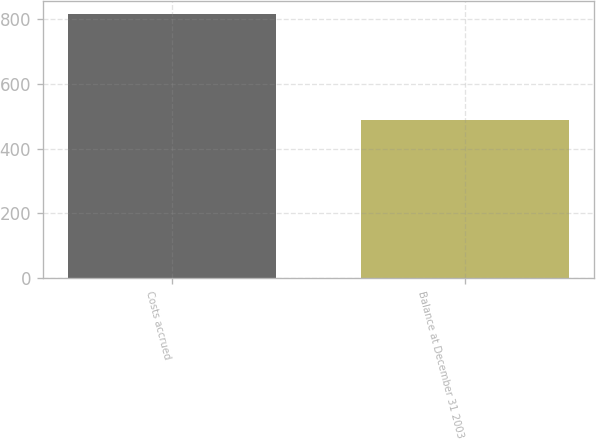<chart> <loc_0><loc_0><loc_500><loc_500><bar_chart><fcel>Costs accrued<fcel>Balance at December 31 2003<nl><fcel>816<fcel>490<nl></chart> 